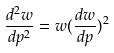<formula> <loc_0><loc_0><loc_500><loc_500>\frac { d ^ { 2 } w } { d p ^ { 2 } } = w ( \frac { d w } { d p } ) ^ { 2 }</formula> 